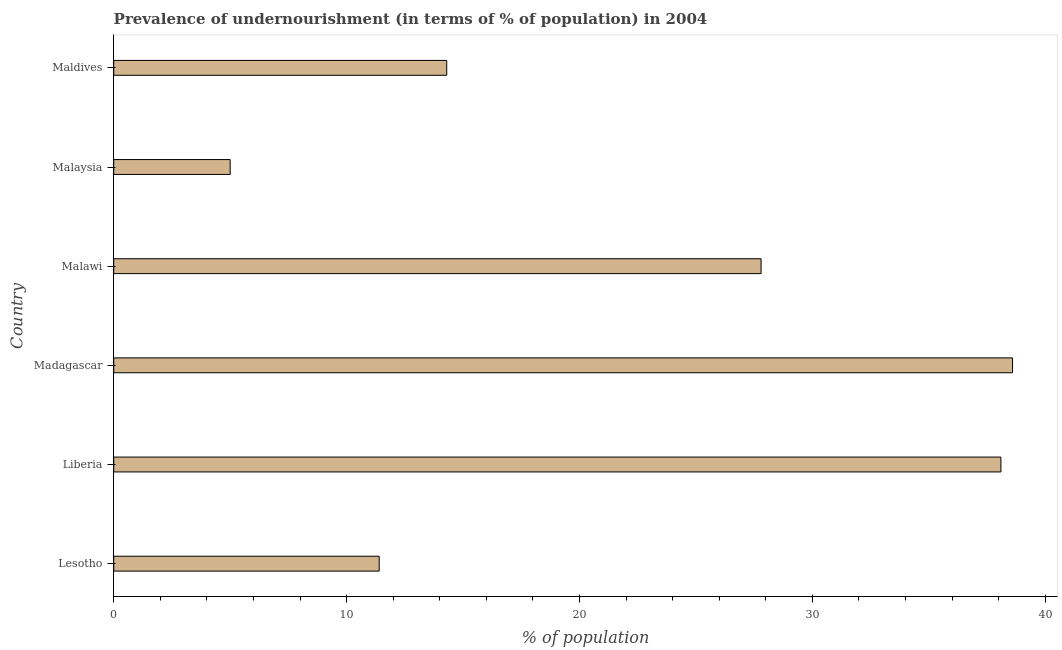Does the graph contain any zero values?
Offer a terse response. No. Does the graph contain grids?
Give a very brief answer. No. What is the title of the graph?
Your response must be concise. Prevalence of undernourishment (in terms of % of population) in 2004. What is the label or title of the X-axis?
Give a very brief answer. % of population. What is the label or title of the Y-axis?
Make the answer very short. Country. What is the percentage of undernourished population in Madagascar?
Offer a terse response. 38.6. Across all countries, what is the maximum percentage of undernourished population?
Offer a very short reply. 38.6. In which country was the percentage of undernourished population maximum?
Your answer should be very brief. Madagascar. In which country was the percentage of undernourished population minimum?
Provide a short and direct response. Malaysia. What is the sum of the percentage of undernourished population?
Provide a short and direct response. 135.2. What is the difference between the percentage of undernourished population in Malaysia and Maldives?
Offer a very short reply. -9.3. What is the average percentage of undernourished population per country?
Give a very brief answer. 22.53. What is the median percentage of undernourished population?
Your response must be concise. 21.05. In how many countries, is the percentage of undernourished population greater than 36 %?
Offer a terse response. 2. What is the ratio of the percentage of undernourished population in Liberia to that in Malawi?
Give a very brief answer. 1.37. Is the difference between the percentage of undernourished population in Madagascar and Malaysia greater than the difference between any two countries?
Offer a terse response. Yes. What is the difference between the highest and the lowest percentage of undernourished population?
Your answer should be compact. 33.6. How many bars are there?
Offer a very short reply. 6. How many countries are there in the graph?
Keep it short and to the point. 6. What is the difference between two consecutive major ticks on the X-axis?
Give a very brief answer. 10. What is the % of population in Liberia?
Keep it short and to the point. 38.1. What is the % of population in Madagascar?
Offer a very short reply. 38.6. What is the % of population in Malawi?
Ensure brevity in your answer.  27.8. What is the % of population in Malaysia?
Provide a short and direct response. 5. What is the % of population of Maldives?
Your response must be concise. 14.3. What is the difference between the % of population in Lesotho and Liberia?
Offer a very short reply. -26.7. What is the difference between the % of population in Lesotho and Madagascar?
Offer a very short reply. -27.2. What is the difference between the % of population in Lesotho and Malawi?
Provide a succinct answer. -16.4. What is the difference between the % of population in Lesotho and Maldives?
Your answer should be very brief. -2.9. What is the difference between the % of population in Liberia and Malawi?
Offer a very short reply. 10.3. What is the difference between the % of population in Liberia and Malaysia?
Your response must be concise. 33.1. What is the difference between the % of population in Liberia and Maldives?
Provide a short and direct response. 23.8. What is the difference between the % of population in Madagascar and Malawi?
Provide a short and direct response. 10.8. What is the difference between the % of population in Madagascar and Malaysia?
Make the answer very short. 33.6. What is the difference between the % of population in Madagascar and Maldives?
Your answer should be very brief. 24.3. What is the difference between the % of population in Malawi and Malaysia?
Keep it short and to the point. 22.8. What is the difference between the % of population in Malawi and Maldives?
Your answer should be very brief. 13.5. What is the difference between the % of population in Malaysia and Maldives?
Keep it short and to the point. -9.3. What is the ratio of the % of population in Lesotho to that in Liberia?
Provide a short and direct response. 0.3. What is the ratio of the % of population in Lesotho to that in Madagascar?
Provide a succinct answer. 0.29. What is the ratio of the % of population in Lesotho to that in Malawi?
Keep it short and to the point. 0.41. What is the ratio of the % of population in Lesotho to that in Malaysia?
Offer a very short reply. 2.28. What is the ratio of the % of population in Lesotho to that in Maldives?
Ensure brevity in your answer.  0.8. What is the ratio of the % of population in Liberia to that in Malawi?
Offer a terse response. 1.37. What is the ratio of the % of population in Liberia to that in Malaysia?
Provide a short and direct response. 7.62. What is the ratio of the % of population in Liberia to that in Maldives?
Your response must be concise. 2.66. What is the ratio of the % of population in Madagascar to that in Malawi?
Your response must be concise. 1.39. What is the ratio of the % of population in Madagascar to that in Malaysia?
Give a very brief answer. 7.72. What is the ratio of the % of population in Madagascar to that in Maldives?
Ensure brevity in your answer.  2.7. What is the ratio of the % of population in Malawi to that in Malaysia?
Your answer should be compact. 5.56. What is the ratio of the % of population in Malawi to that in Maldives?
Keep it short and to the point. 1.94. 